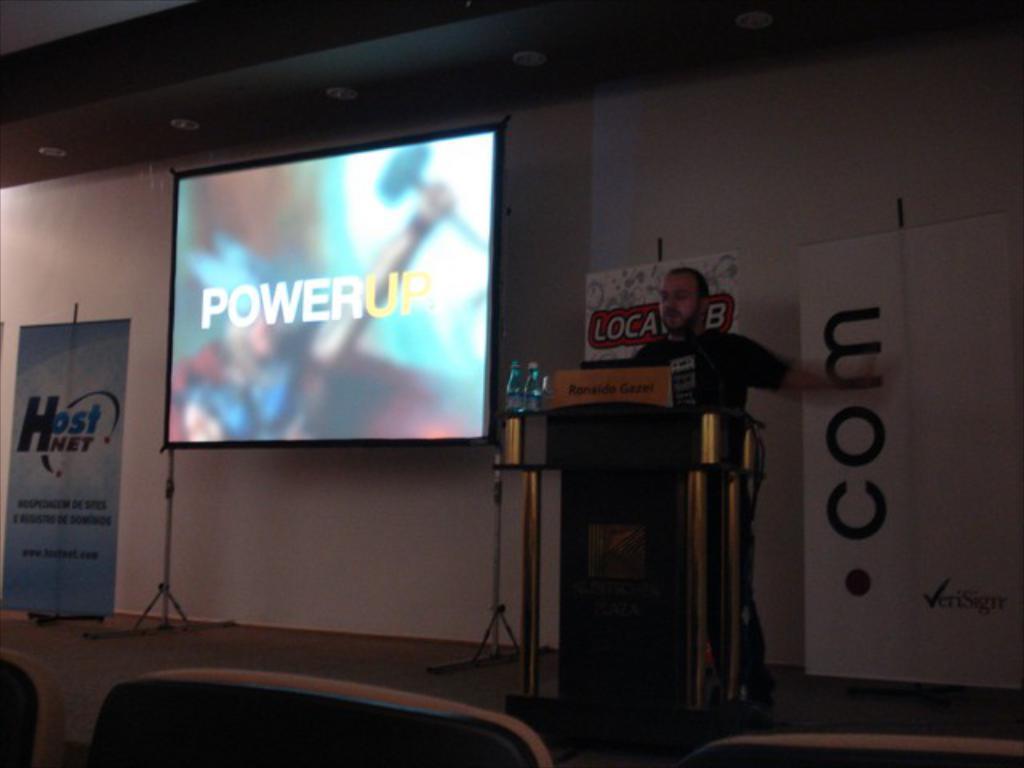What word is on the display at the front of the room?
Keep it short and to the point. Powerup. 